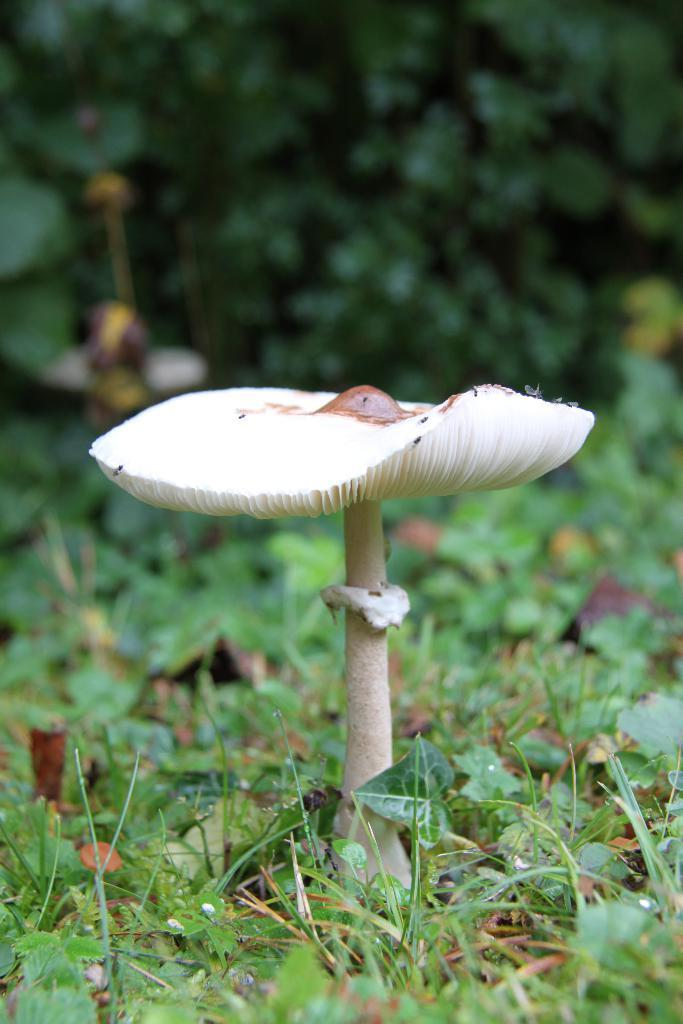What type of fungus can be seen in the image? There is a mushroom in the image. What type of vegetation is visible in the image? There is grass and plants visible in the image. What type of card is being used to grip the mushroom in the image? There is no card or grip action present in the image; it simply shows a mushroom and vegetation. 